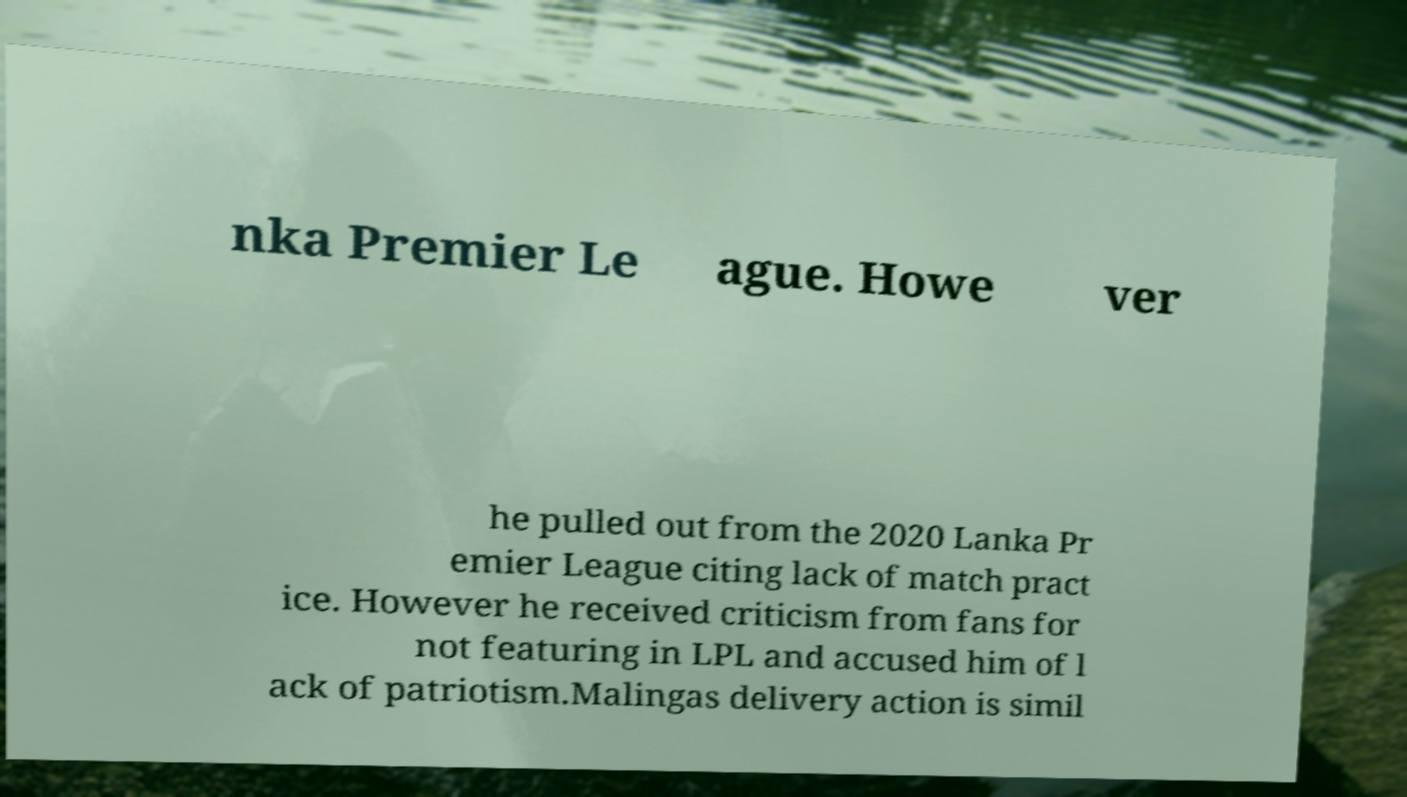There's text embedded in this image that I need extracted. Can you transcribe it verbatim? nka Premier Le ague. Howe ver he pulled out from the 2020 Lanka Pr emier League citing lack of match pract ice. However he received criticism from fans for not featuring in LPL and accused him of l ack of patriotism.Malingas delivery action is simil 